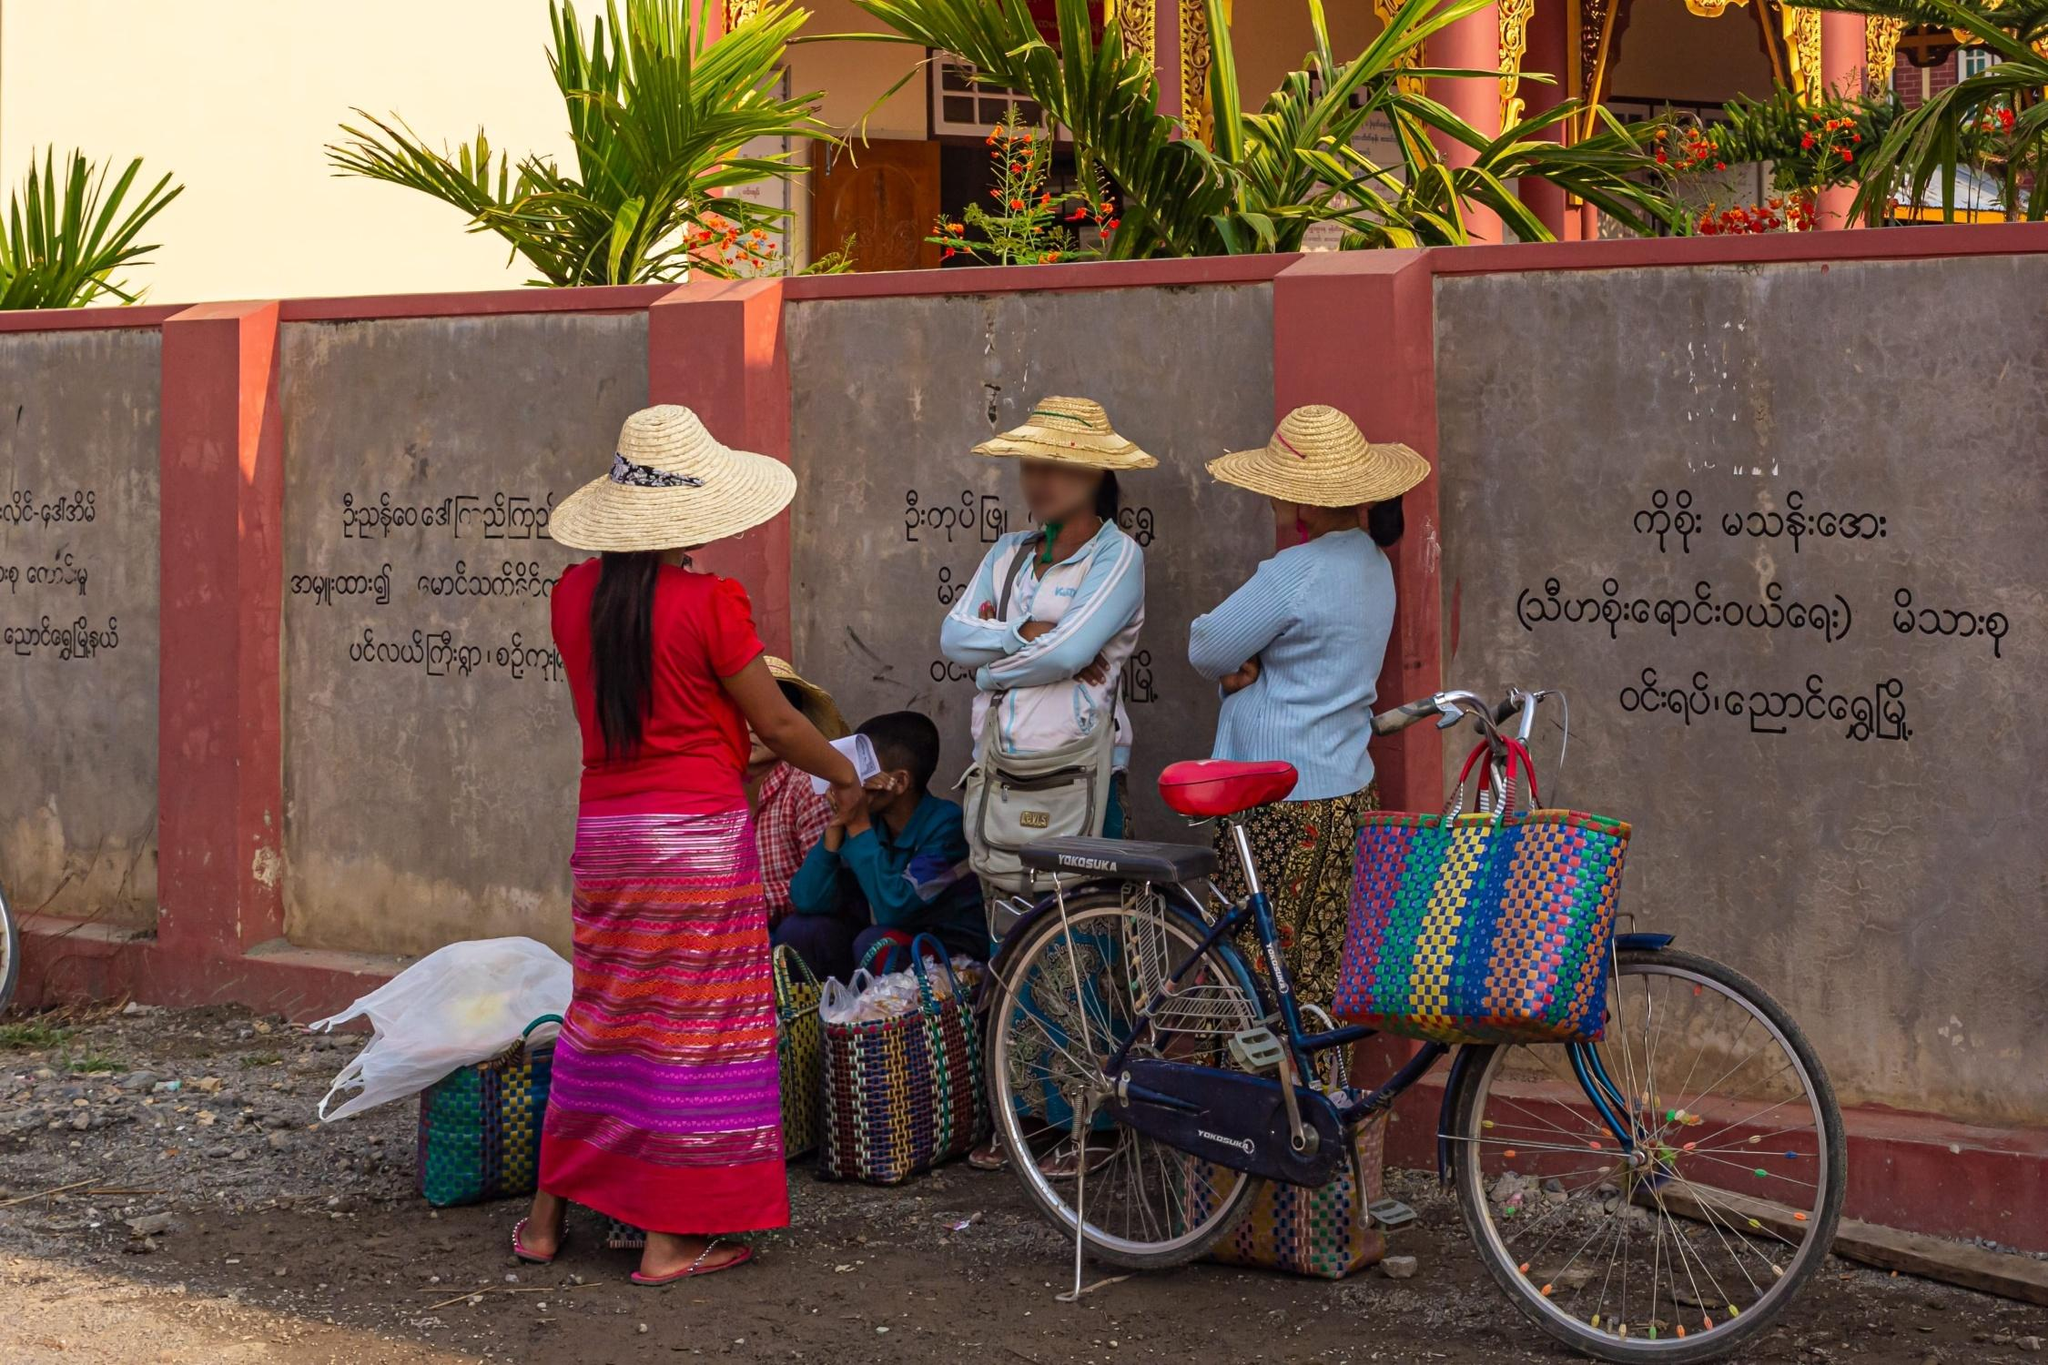Explain the visual content of the image in great detail. The image presents a vivid, daily life scene involving several individuals at a roadside. A focal point in the image is a red bicycle, adorned with a vibrant, patterned basket filled with goods, possibly indicating that the bicycle is used for carrying goods or personal belongings. The people, including women and a young boy, are dressed in colorful traditional attire that suggests a Southeast Asian cultural setting, possibly Myanmar judging by the script on the wall. Two women are wearing wide-brimmed hats, which are typically used for sun protection in rural areas. The group is engaged in what appears to be a casual exchange or a transaction, suggesting a local market scene or a community gathering point, highlighted by baskets and bags indicating shopping or trade activities. The background features a decorative temple wall with Burmese script, which might indicate religious or cultural significance in the location. 